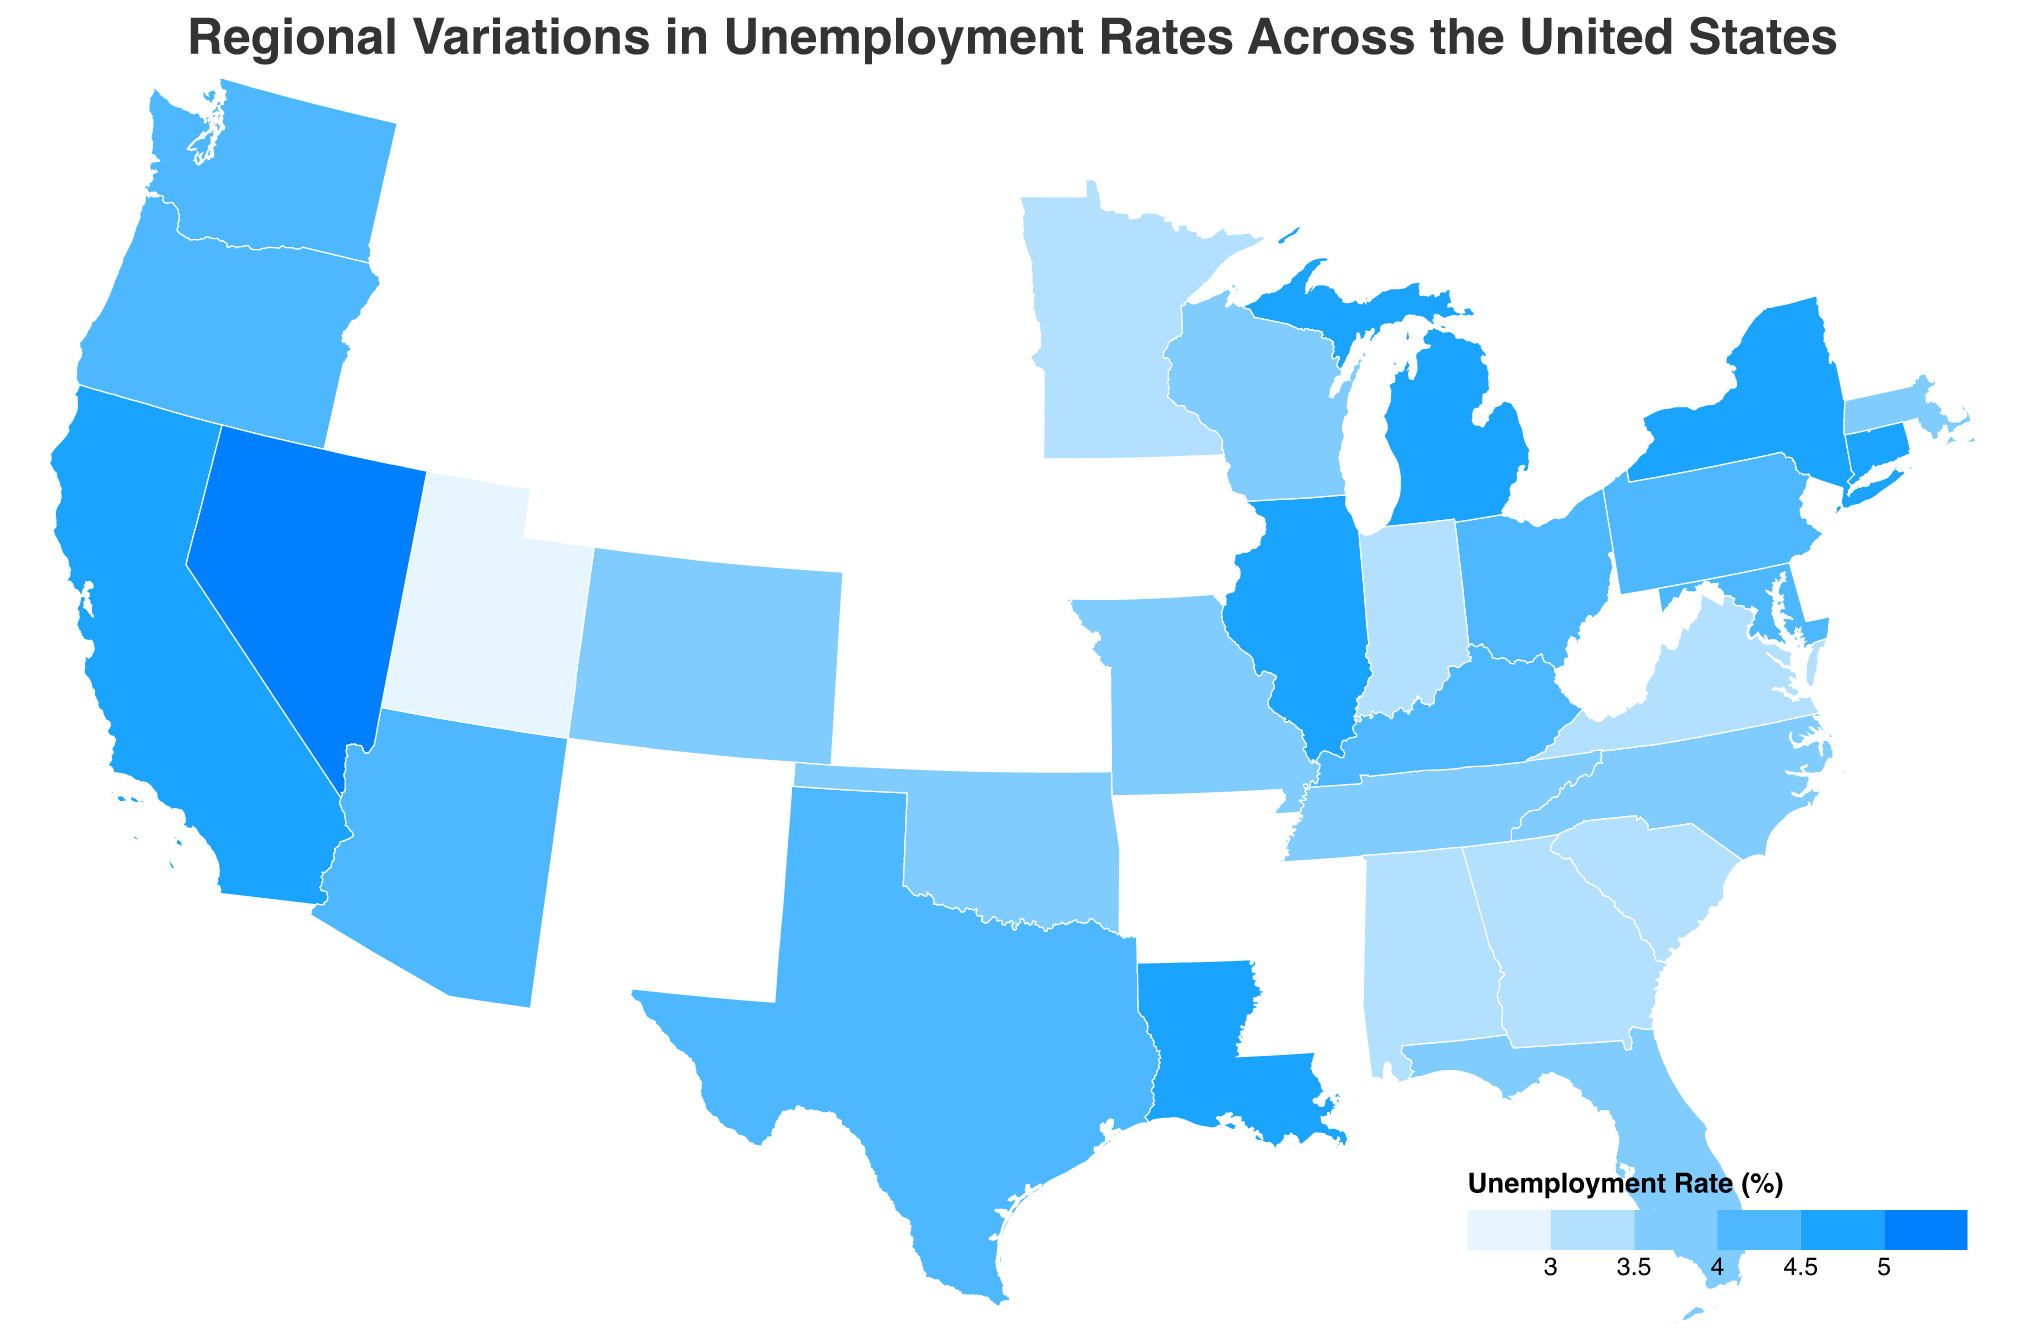What's the title of the figure? The title of the figure is located at the top and generally provides a summary of what the figure represents.
Answer: Regional Variations in Unemployment Rates Across the United States Which state has the highest unemployment rate? The state with the highest unemployment rate will be represented by the darkest color on the scale used in the figure.
Answer: Nevada Which state has the lowest unemployment rate? The state with the lowest unemployment rate will be represented by the lightest color on the scale used in the figure.
Answer: Utah How does California's unemployment rate compare to the national average shown in the plot? The figure uses color to represent different ranges of unemployment rates. By comparing California's color to the colors on the legend, we can determine how it compares to the national average depicted.
Answer: California's rate (4.8) is above the middle range Are there more states with unemployment rates above or below 4%? To answer this, count the number of states in colors representing below 4% and those representing above 4%, based on the color legend.
Answer: More states are below 4% Which region of the U.S. tends to have lower unemployment rates judging by the plot? By observing the concentration of colors representing lower unemployment rates, we can determine the region with generally lower unemployment rates. For instance, many states in the Southeast appear to have lower rates.
Answer: Southeast Compare the unemployment rate of Texas and New York. Which one is higher? Locate both Texas and New York on the plot, then compare the colors or the exact rates given in the tooltip.
Answer: New York What's the difference between the unemployment rates of Utah and Nevada? Find Utah and Nevada on the map, note their unemployment rates, and calculate the difference.
Answer: 2.2% Identify two states with almost identical unemployment rates and describe their rates. Look for states in the plots that have a similar color and verify by checking the tooltip information for their exact rates.
Answer: Texas and Maryland, both at 4.2% Which state has a moderately high unemployment rate but not the highest, and how does it compare to the rest? Determine a state that has one of the darker shades but isn't the darkest, indicating a higher but not the highest rate. Compare it to other states using the legend and tooltips.
Answer: California with 4.8%, which is higher than many but not the highest What unemployment rate range do the majority of states fall into based on the plot's color legend? Count the number of states within each color range on the legend to see which range has the most states.
Answer: 3.5%-4.0% 